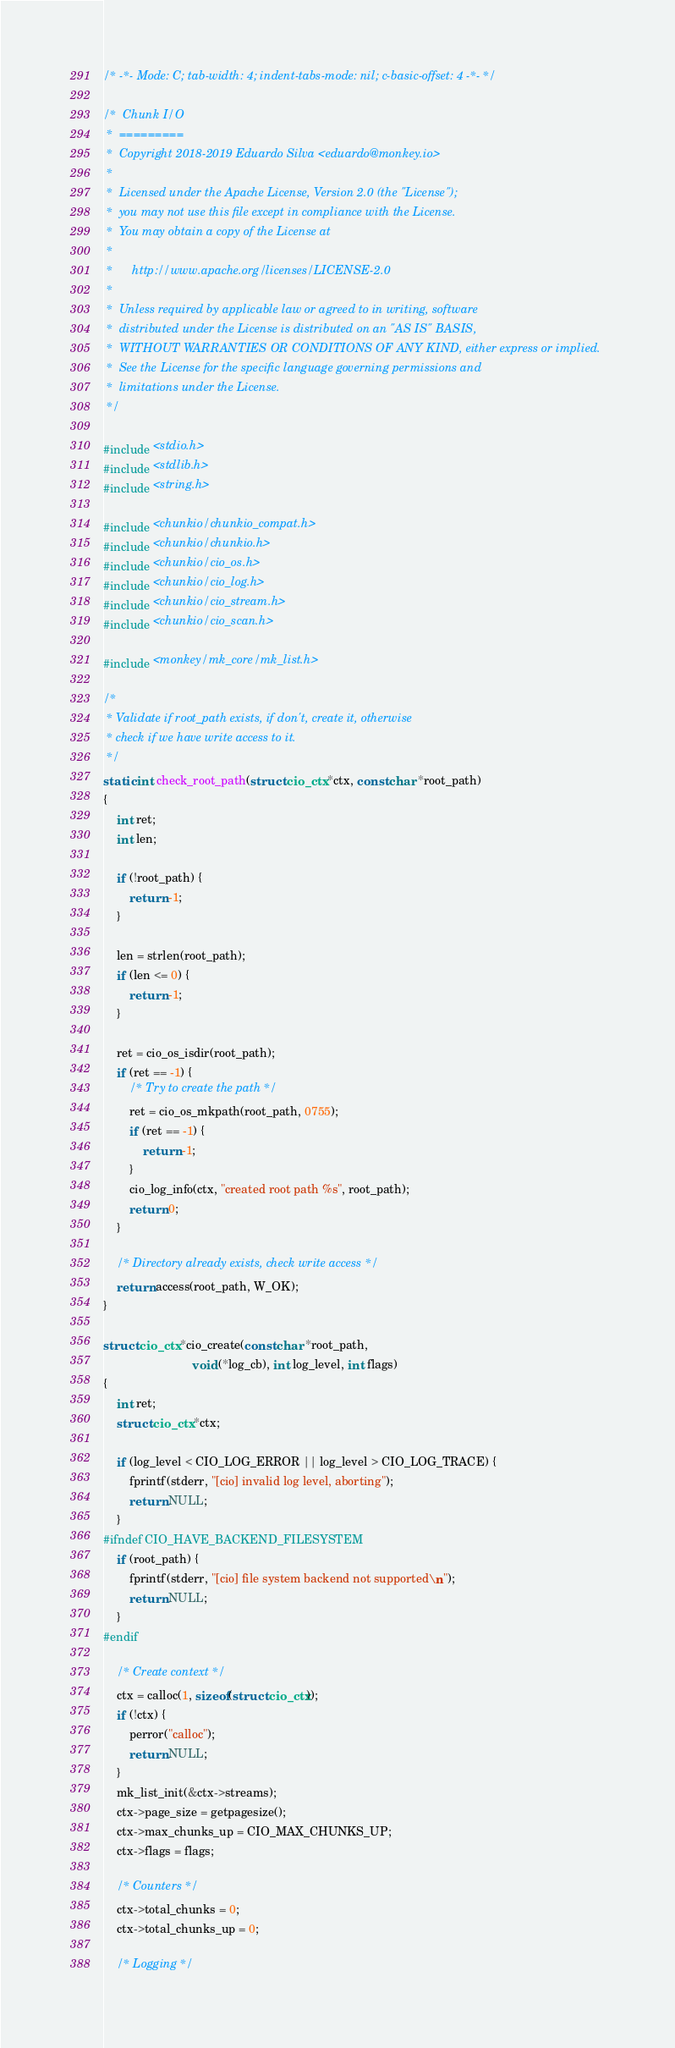Convert code to text. <code><loc_0><loc_0><loc_500><loc_500><_C_>/* -*- Mode: C; tab-width: 4; indent-tabs-mode: nil; c-basic-offset: 4 -*- */

/*  Chunk I/O
 *  =========
 *  Copyright 2018-2019 Eduardo Silva <eduardo@monkey.io>
 *
 *  Licensed under the Apache License, Version 2.0 (the "License");
 *  you may not use this file except in compliance with the License.
 *  You may obtain a copy of the License at
 *
 *      http://www.apache.org/licenses/LICENSE-2.0
 *
 *  Unless required by applicable law or agreed to in writing, software
 *  distributed under the License is distributed on an "AS IS" BASIS,
 *  WITHOUT WARRANTIES OR CONDITIONS OF ANY KIND, either express or implied.
 *  See the License for the specific language governing permissions and
 *  limitations under the License.
 */

#include <stdio.h>
#include <stdlib.h>
#include <string.h>

#include <chunkio/chunkio_compat.h>
#include <chunkio/chunkio.h>
#include <chunkio/cio_os.h>
#include <chunkio/cio_log.h>
#include <chunkio/cio_stream.h>
#include <chunkio/cio_scan.h>

#include <monkey/mk_core/mk_list.h>

/*
 * Validate if root_path exists, if don't, create it, otherwise
 * check if we have write access to it.
 */
static int check_root_path(struct cio_ctx *ctx, const char *root_path)
{
    int ret;
    int len;

    if (!root_path) {
        return -1;
    }

    len = strlen(root_path);
    if (len <= 0) {
        return -1;
    }

    ret = cio_os_isdir(root_path);
    if (ret == -1) {
        /* Try to create the path */
        ret = cio_os_mkpath(root_path, 0755);
        if (ret == -1) {
            return -1;
        }
        cio_log_info(ctx, "created root path %s", root_path);
        return 0;
    }

    /* Directory already exists, check write access */
    return access(root_path, W_OK);
}

struct cio_ctx *cio_create(const char *root_path,
                           void (*log_cb), int log_level, int flags)
{
    int ret;
    struct cio_ctx *ctx;

    if (log_level < CIO_LOG_ERROR || log_level > CIO_LOG_TRACE) {
        fprintf(stderr, "[cio] invalid log level, aborting");
        return NULL;
    }
#ifndef CIO_HAVE_BACKEND_FILESYSTEM
    if (root_path) {
        fprintf(stderr, "[cio] file system backend not supported\n");
        return NULL;
    }
#endif

    /* Create context */
    ctx = calloc(1, sizeof(struct cio_ctx));
    if (!ctx) {
        perror("calloc");
        return NULL;
    }
    mk_list_init(&ctx->streams);
    ctx->page_size = getpagesize();
    ctx->max_chunks_up = CIO_MAX_CHUNKS_UP;
    ctx->flags = flags;

    /* Counters */
    ctx->total_chunks = 0;
    ctx->total_chunks_up = 0;

    /* Logging */</code> 